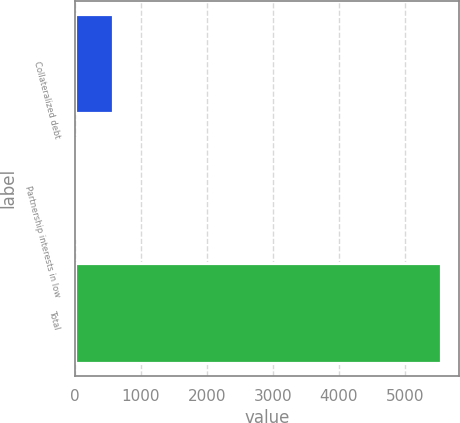Convert chart. <chart><loc_0><loc_0><loc_500><loc_500><bar_chart><fcel>Collateralized debt<fcel>Partnership interests in low<fcel>Total<nl><fcel>584.7<fcel>34<fcel>5541<nl></chart> 